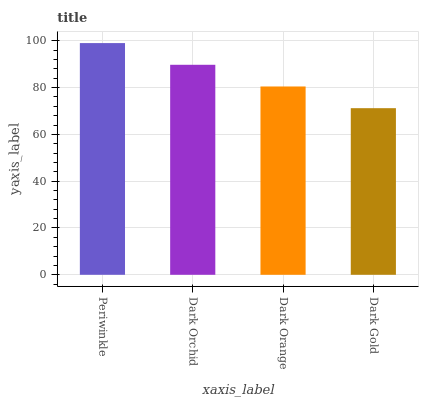Is Dark Orchid the minimum?
Answer yes or no. No. Is Dark Orchid the maximum?
Answer yes or no. No. Is Periwinkle greater than Dark Orchid?
Answer yes or no. Yes. Is Dark Orchid less than Periwinkle?
Answer yes or no. Yes. Is Dark Orchid greater than Periwinkle?
Answer yes or no. No. Is Periwinkle less than Dark Orchid?
Answer yes or no. No. Is Dark Orchid the high median?
Answer yes or no. Yes. Is Dark Orange the low median?
Answer yes or no. Yes. Is Periwinkle the high median?
Answer yes or no. No. Is Dark Gold the low median?
Answer yes or no. No. 